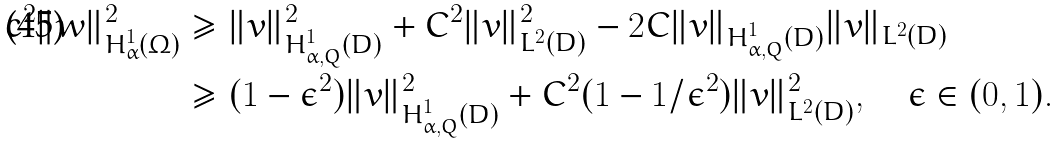Convert formula to latex. <formula><loc_0><loc_0><loc_500><loc_500>c ^ { 2 } \| w \| _ { H ^ { 1 } _ { \alpha } ( \Omega ) } ^ { 2 } & \geq \| v \| _ { H ^ { 1 } _ { \alpha , Q } ( D ) } ^ { 2 } + C ^ { 2 } \| v \| _ { L ^ { 2 } ( D ) } ^ { 2 } - 2 C \| v \| _ { H ^ { 1 } _ { \alpha , Q } ( D ) } \| v \| _ { L ^ { 2 } ( D ) } \\ & \geq ( 1 - \epsilon ^ { 2 } ) \| v \| _ { H ^ { 1 } _ { \alpha , Q } ( D ) } ^ { 2 } + C ^ { 2 } ( 1 - 1 / \epsilon ^ { 2 } ) \| v \| _ { L ^ { 2 } ( D ) } ^ { 2 } , \quad \epsilon \in ( 0 , 1 ) .</formula> 